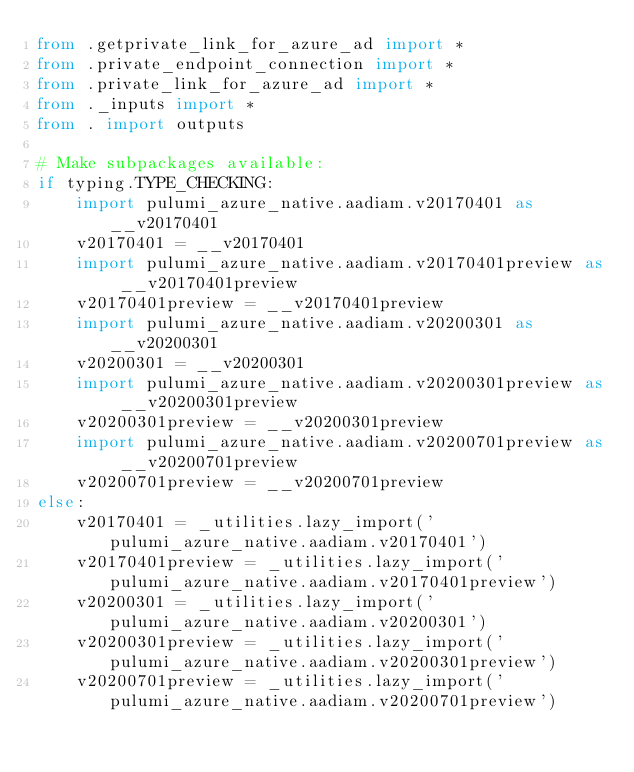Convert code to text. <code><loc_0><loc_0><loc_500><loc_500><_Python_>from .getprivate_link_for_azure_ad import *
from .private_endpoint_connection import *
from .private_link_for_azure_ad import *
from ._inputs import *
from . import outputs

# Make subpackages available:
if typing.TYPE_CHECKING:
    import pulumi_azure_native.aadiam.v20170401 as __v20170401
    v20170401 = __v20170401
    import pulumi_azure_native.aadiam.v20170401preview as __v20170401preview
    v20170401preview = __v20170401preview
    import pulumi_azure_native.aadiam.v20200301 as __v20200301
    v20200301 = __v20200301
    import pulumi_azure_native.aadiam.v20200301preview as __v20200301preview
    v20200301preview = __v20200301preview
    import pulumi_azure_native.aadiam.v20200701preview as __v20200701preview
    v20200701preview = __v20200701preview
else:
    v20170401 = _utilities.lazy_import('pulumi_azure_native.aadiam.v20170401')
    v20170401preview = _utilities.lazy_import('pulumi_azure_native.aadiam.v20170401preview')
    v20200301 = _utilities.lazy_import('pulumi_azure_native.aadiam.v20200301')
    v20200301preview = _utilities.lazy_import('pulumi_azure_native.aadiam.v20200301preview')
    v20200701preview = _utilities.lazy_import('pulumi_azure_native.aadiam.v20200701preview')

</code> 